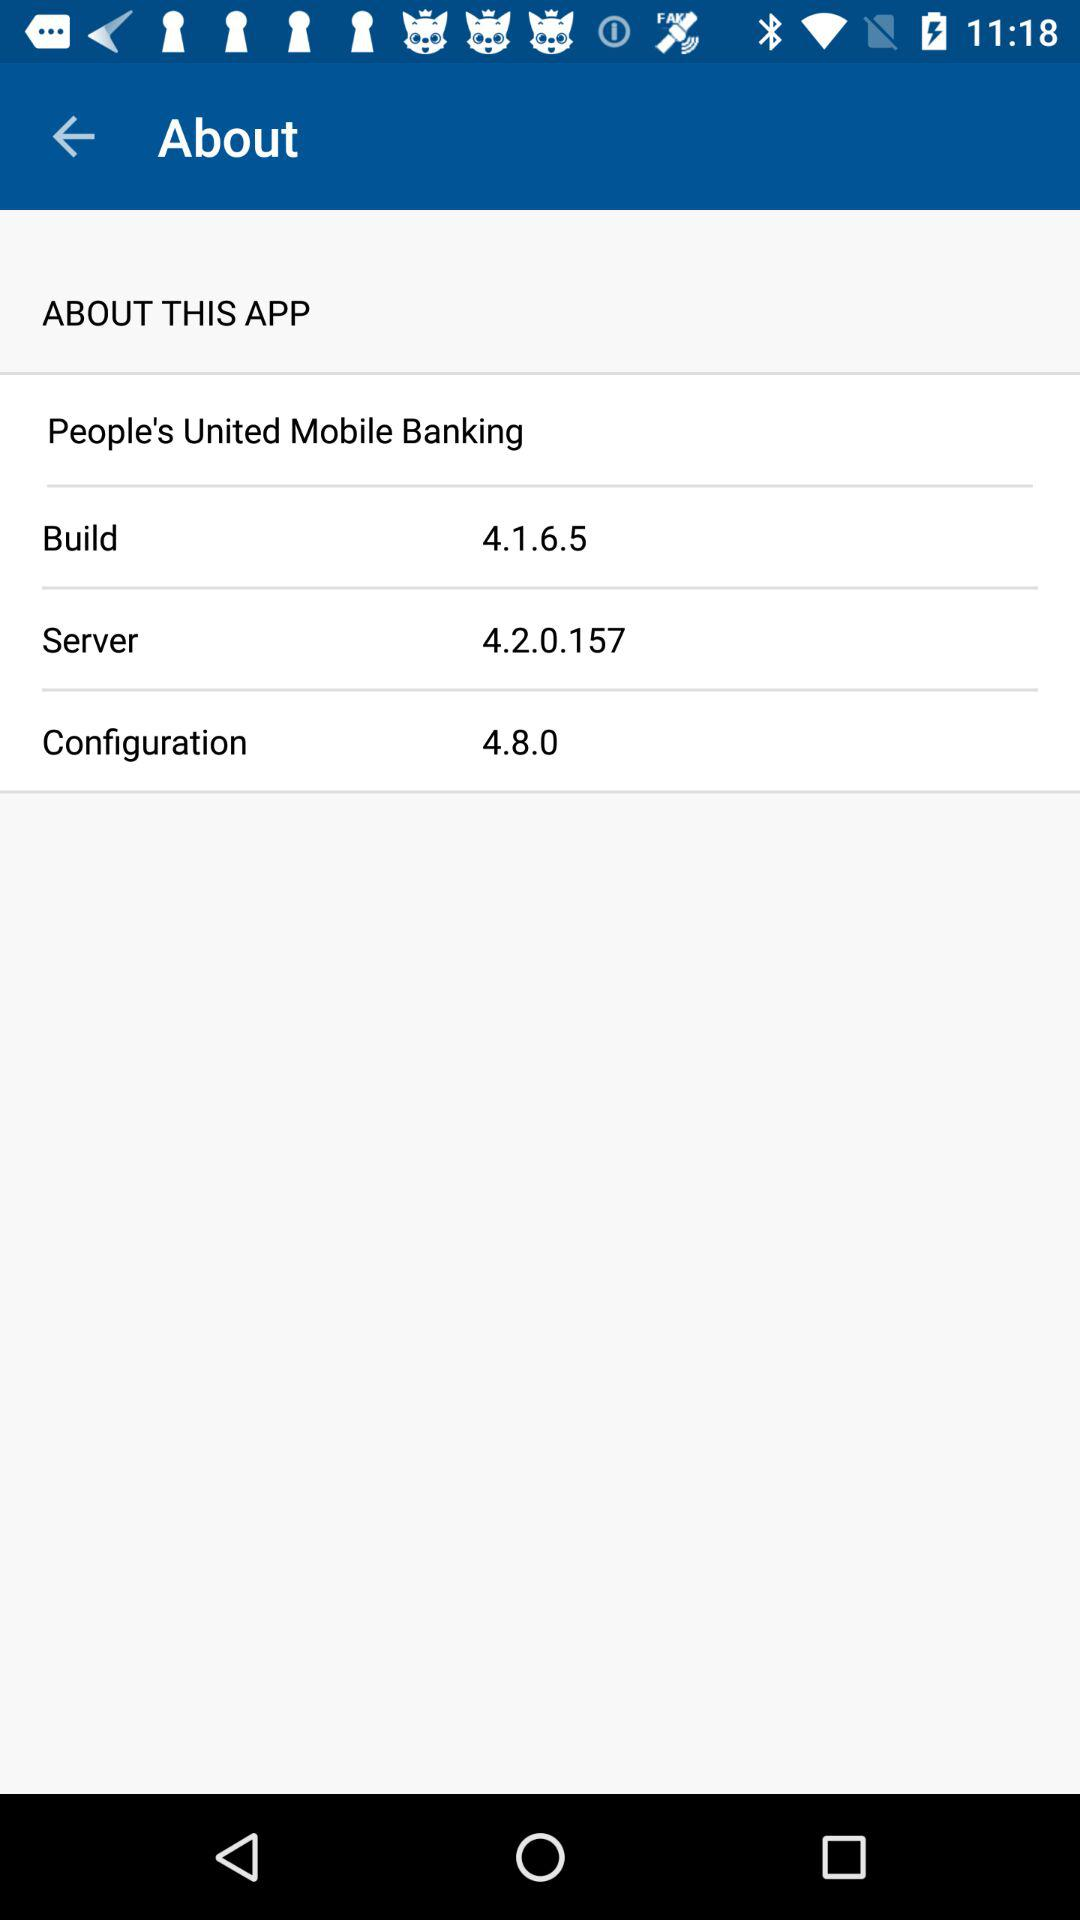What is the build number? The build number is 4.1.6.5. 